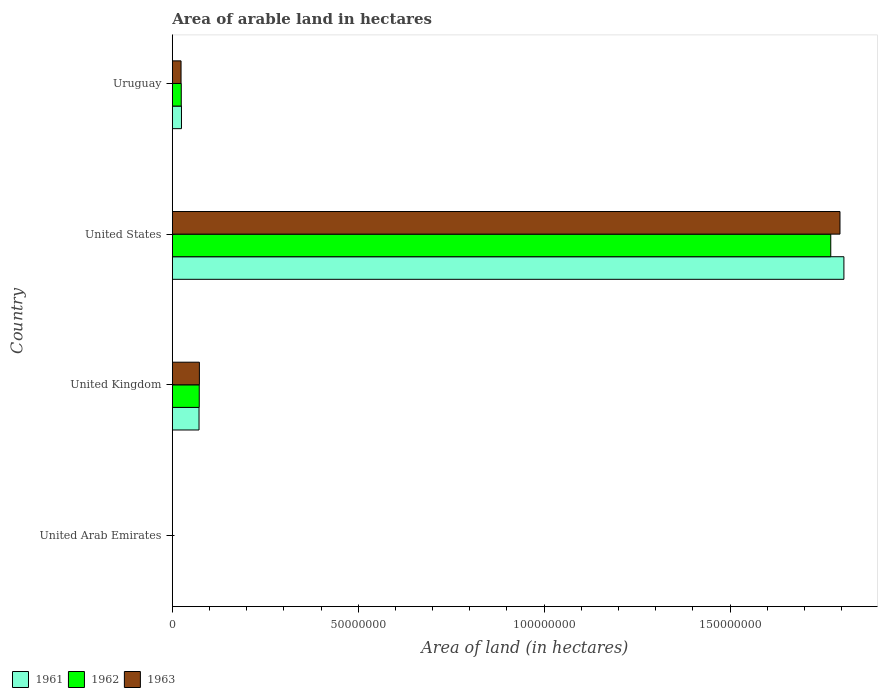How many bars are there on the 4th tick from the bottom?
Your answer should be compact. 3. What is the total arable land in 1962 in United Arab Emirates?
Your response must be concise. 5000. Across all countries, what is the maximum total arable land in 1963?
Ensure brevity in your answer.  1.80e+08. Across all countries, what is the minimum total arable land in 1963?
Provide a succinct answer. 5000. In which country was the total arable land in 1962 minimum?
Your answer should be compact. United Arab Emirates. What is the total total arable land in 1962 in the graph?
Make the answer very short. 1.87e+08. What is the difference between the total arable land in 1962 in United Kingdom and that in United States?
Provide a succinct answer. -1.70e+08. What is the difference between the total arable land in 1961 in United Kingdom and the total arable land in 1963 in United States?
Your response must be concise. -1.72e+08. What is the average total arable land in 1961 per country?
Provide a succinct answer. 4.76e+07. What is the difference between the total arable land in 1961 and total arable land in 1962 in United Kingdom?
Ensure brevity in your answer.  -6.10e+04. In how many countries, is the total arable land in 1963 greater than 20000000 hectares?
Ensure brevity in your answer.  1. What is the ratio of the total arable land in 1963 in United Kingdom to that in Uruguay?
Offer a very short reply. 3.11. Is the difference between the total arable land in 1961 in United Kingdom and United States greater than the difference between the total arable land in 1962 in United Kingdom and United States?
Your response must be concise. No. What is the difference between the highest and the second highest total arable land in 1961?
Your response must be concise. 1.73e+08. What is the difference between the highest and the lowest total arable land in 1961?
Offer a terse response. 1.81e+08. Is it the case that in every country, the sum of the total arable land in 1962 and total arable land in 1961 is greater than the total arable land in 1963?
Provide a succinct answer. Yes. How many bars are there?
Provide a succinct answer. 12. Are all the bars in the graph horizontal?
Offer a very short reply. Yes. What is the difference between two consecutive major ticks on the X-axis?
Your answer should be compact. 5.00e+07. Does the graph contain any zero values?
Give a very brief answer. No. Does the graph contain grids?
Make the answer very short. No. How are the legend labels stacked?
Your answer should be compact. Horizontal. What is the title of the graph?
Your response must be concise. Area of arable land in hectares. Does "2000" appear as one of the legend labels in the graph?
Provide a succinct answer. No. What is the label or title of the X-axis?
Make the answer very short. Area of land (in hectares). What is the label or title of the Y-axis?
Provide a succinct answer. Country. What is the Area of land (in hectares) in 1963 in United Arab Emirates?
Provide a short and direct response. 5000. What is the Area of land (in hectares) of 1961 in United Kingdom?
Make the answer very short. 7.18e+06. What is the Area of land (in hectares) of 1962 in United Kingdom?
Make the answer very short. 7.24e+06. What is the Area of land (in hectares) in 1963 in United Kingdom?
Your answer should be compact. 7.28e+06. What is the Area of land (in hectares) of 1961 in United States?
Provide a succinct answer. 1.81e+08. What is the Area of land (in hectares) in 1962 in United States?
Your answer should be very brief. 1.77e+08. What is the Area of land (in hectares) of 1963 in United States?
Make the answer very short. 1.80e+08. What is the Area of land (in hectares) in 1961 in Uruguay?
Provide a succinct answer. 2.45e+06. What is the Area of land (in hectares) of 1962 in Uruguay?
Your answer should be very brief. 2.40e+06. What is the Area of land (in hectares) of 1963 in Uruguay?
Offer a terse response. 2.34e+06. Across all countries, what is the maximum Area of land (in hectares) of 1961?
Give a very brief answer. 1.81e+08. Across all countries, what is the maximum Area of land (in hectares) of 1962?
Keep it short and to the point. 1.77e+08. Across all countries, what is the maximum Area of land (in hectares) in 1963?
Provide a short and direct response. 1.80e+08. Across all countries, what is the minimum Area of land (in hectares) in 1962?
Give a very brief answer. 5000. What is the total Area of land (in hectares) in 1961 in the graph?
Offer a very short reply. 1.90e+08. What is the total Area of land (in hectares) in 1962 in the graph?
Offer a very short reply. 1.87e+08. What is the total Area of land (in hectares) in 1963 in the graph?
Your response must be concise. 1.89e+08. What is the difference between the Area of land (in hectares) of 1961 in United Arab Emirates and that in United Kingdom?
Your answer should be compact. -7.17e+06. What is the difference between the Area of land (in hectares) in 1962 in United Arab Emirates and that in United Kingdom?
Give a very brief answer. -7.23e+06. What is the difference between the Area of land (in hectares) in 1963 in United Arab Emirates and that in United Kingdom?
Make the answer very short. -7.27e+06. What is the difference between the Area of land (in hectares) in 1961 in United Arab Emirates and that in United States?
Ensure brevity in your answer.  -1.81e+08. What is the difference between the Area of land (in hectares) in 1962 in United Arab Emirates and that in United States?
Your response must be concise. -1.77e+08. What is the difference between the Area of land (in hectares) in 1963 in United Arab Emirates and that in United States?
Give a very brief answer. -1.80e+08. What is the difference between the Area of land (in hectares) in 1961 in United Arab Emirates and that in Uruguay?
Ensure brevity in your answer.  -2.45e+06. What is the difference between the Area of land (in hectares) of 1962 in United Arab Emirates and that in Uruguay?
Keep it short and to the point. -2.39e+06. What is the difference between the Area of land (in hectares) in 1963 in United Arab Emirates and that in Uruguay?
Your response must be concise. -2.33e+06. What is the difference between the Area of land (in hectares) of 1961 in United Kingdom and that in United States?
Your response must be concise. -1.73e+08. What is the difference between the Area of land (in hectares) of 1962 in United Kingdom and that in United States?
Give a very brief answer. -1.70e+08. What is the difference between the Area of land (in hectares) of 1963 in United Kingdom and that in United States?
Ensure brevity in your answer.  -1.72e+08. What is the difference between the Area of land (in hectares) of 1961 in United Kingdom and that in Uruguay?
Your answer should be compact. 4.72e+06. What is the difference between the Area of land (in hectares) of 1962 in United Kingdom and that in Uruguay?
Your answer should be compact. 4.84e+06. What is the difference between the Area of land (in hectares) of 1963 in United Kingdom and that in Uruguay?
Your answer should be compact. 4.94e+06. What is the difference between the Area of land (in hectares) in 1961 in United States and that in Uruguay?
Offer a terse response. 1.78e+08. What is the difference between the Area of land (in hectares) of 1962 in United States and that in Uruguay?
Provide a short and direct response. 1.75e+08. What is the difference between the Area of land (in hectares) in 1963 in United States and that in Uruguay?
Offer a very short reply. 1.77e+08. What is the difference between the Area of land (in hectares) of 1961 in United Arab Emirates and the Area of land (in hectares) of 1962 in United Kingdom?
Your answer should be very brief. -7.23e+06. What is the difference between the Area of land (in hectares) of 1961 in United Arab Emirates and the Area of land (in hectares) of 1963 in United Kingdom?
Make the answer very short. -7.27e+06. What is the difference between the Area of land (in hectares) in 1962 in United Arab Emirates and the Area of land (in hectares) in 1963 in United Kingdom?
Make the answer very short. -7.27e+06. What is the difference between the Area of land (in hectares) of 1961 in United Arab Emirates and the Area of land (in hectares) of 1962 in United States?
Ensure brevity in your answer.  -1.77e+08. What is the difference between the Area of land (in hectares) of 1961 in United Arab Emirates and the Area of land (in hectares) of 1963 in United States?
Offer a terse response. -1.80e+08. What is the difference between the Area of land (in hectares) in 1962 in United Arab Emirates and the Area of land (in hectares) in 1963 in United States?
Provide a short and direct response. -1.80e+08. What is the difference between the Area of land (in hectares) in 1961 in United Arab Emirates and the Area of land (in hectares) in 1962 in Uruguay?
Provide a succinct answer. -2.39e+06. What is the difference between the Area of land (in hectares) of 1961 in United Arab Emirates and the Area of land (in hectares) of 1963 in Uruguay?
Provide a succinct answer. -2.33e+06. What is the difference between the Area of land (in hectares) in 1962 in United Arab Emirates and the Area of land (in hectares) in 1963 in Uruguay?
Ensure brevity in your answer.  -2.33e+06. What is the difference between the Area of land (in hectares) of 1961 in United Kingdom and the Area of land (in hectares) of 1962 in United States?
Provide a succinct answer. -1.70e+08. What is the difference between the Area of land (in hectares) in 1961 in United Kingdom and the Area of land (in hectares) in 1963 in United States?
Keep it short and to the point. -1.72e+08. What is the difference between the Area of land (in hectares) in 1962 in United Kingdom and the Area of land (in hectares) in 1963 in United States?
Offer a very short reply. -1.72e+08. What is the difference between the Area of land (in hectares) in 1961 in United Kingdom and the Area of land (in hectares) in 1962 in Uruguay?
Provide a short and direct response. 4.78e+06. What is the difference between the Area of land (in hectares) of 1961 in United Kingdom and the Area of land (in hectares) of 1963 in Uruguay?
Your response must be concise. 4.84e+06. What is the difference between the Area of land (in hectares) in 1962 in United Kingdom and the Area of land (in hectares) in 1963 in Uruguay?
Offer a terse response. 4.90e+06. What is the difference between the Area of land (in hectares) in 1961 in United States and the Area of land (in hectares) in 1962 in Uruguay?
Your response must be concise. 1.78e+08. What is the difference between the Area of land (in hectares) of 1961 in United States and the Area of land (in hectares) of 1963 in Uruguay?
Provide a short and direct response. 1.78e+08. What is the difference between the Area of land (in hectares) in 1962 in United States and the Area of land (in hectares) in 1963 in Uruguay?
Provide a short and direct response. 1.75e+08. What is the average Area of land (in hectares) of 1961 per country?
Provide a short and direct response. 4.76e+07. What is the average Area of land (in hectares) in 1962 per country?
Offer a very short reply. 4.67e+07. What is the average Area of land (in hectares) in 1963 per country?
Provide a succinct answer. 4.73e+07. What is the difference between the Area of land (in hectares) of 1962 and Area of land (in hectares) of 1963 in United Arab Emirates?
Make the answer very short. 0. What is the difference between the Area of land (in hectares) in 1961 and Area of land (in hectares) in 1962 in United Kingdom?
Ensure brevity in your answer.  -6.10e+04. What is the difference between the Area of land (in hectares) of 1961 and Area of land (in hectares) of 1963 in United Kingdom?
Your response must be concise. -1.00e+05. What is the difference between the Area of land (in hectares) of 1962 and Area of land (in hectares) of 1963 in United Kingdom?
Provide a succinct answer. -3.90e+04. What is the difference between the Area of land (in hectares) in 1961 and Area of land (in hectares) in 1962 in United States?
Give a very brief answer. 3.54e+06. What is the difference between the Area of land (in hectares) of 1961 and Area of land (in hectares) of 1963 in United States?
Make the answer very short. 1.06e+06. What is the difference between the Area of land (in hectares) in 1962 and Area of land (in hectares) in 1963 in United States?
Your answer should be compact. -2.48e+06. What is the difference between the Area of land (in hectares) of 1961 and Area of land (in hectares) of 1962 in Uruguay?
Your answer should be compact. 5.80e+04. What is the difference between the Area of land (in hectares) of 1961 and Area of land (in hectares) of 1963 in Uruguay?
Provide a succinct answer. 1.16e+05. What is the difference between the Area of land (in hectares) of 1962 and Area of land (in hectares) of 1963 in Uruguay?
Make the answer very short. 5.80e+04. What is the ratio of the Area of land (in hectares) in 1961 in United Arab Emirates to that in United Kingdom?
Provide a succinct answer. 0. What is the ratio of the Area of land (in hectares) of 1962 in United Arab Emirates to that in United Kingdom?
Provide a succinct answer. 0. What is the ratio of the Area of land (in hectares) of 1963 in United Arab Emirates to that in United Kingdom?
Provide a succinct answer. 0. What is the ratio of the Area of land (in hectares) of 1961 in United Arab Emirates to that in United States?
Provide a succinct answer. 0. What is the ratio of the Area of land (in hectares) of 1961 in United Arab Emirates to that in Uruguay?
Keep it short and to the point. 0. What is the ratio of the Area of land (in hectares) of 1962 in United Arab Emirates to that in Uruguay?
Give a very brief answer. 0. What is the ratio of the Area of land (in hectares) in 1963 in United Arab Emirates to that in Uruguay?
Your answer should be very brief. 0. What is the ratio of the Area of land (in hectares) in 1961 in United Kingdom to that in United States?
Offer a very short reply. 0.04. What is the ratio of the Area of land (in hectares) in 1962 in United Kingdom to that in United States?
Provide a succinct answer. 0.04. What is the ratio of the Area of land (in hectares) in 1963 in United Kingdom to that in United States?
Offer a very short reply. 0.04. What is the ratio of the Area of land (in hectares) in 1961 in United Kingdom to that in Uruguay?
Give a very brief answer. 2.92. What is the ratio of the Area of land (in hectares) of 1962 in United Kingdom to that in Uruguay?
Your response must be concise. 3.02. What is the ratio of the Area of land (in hectares) of 1963 in United Kingdom to that in Uruguay?
Your answer should be compact. 3.11. What is the ratio of the Area of land (in hectares) in 1961 in United States to that in Uruguay?
Give a very brief answer. 73.61. What is the ratio of the Area of land (in hectares) in 1962 in United States to that in Uruguay?
Give a very brief answer. 73.91. What is the ratio of the Area of land (in hectares) of 1963 in United States to that in Uruguay?
Make the answer very short. 76.81. What is the difference between the highest and the second highest Area of land (in hectares) of 1961?
Ensure brevity in your answer.  1.73e+08. What is the difference between the highest and the second highest Area of land (in hectares) in 1962?
Your answer should be compact. 1.70e+08. What is the difference between the highest and the second highest Area of land (in hectares) of 1963?
Your answer should be very brief. 1.72e+08. What is the difference between the highest and the lowest Area of land (in hectares) of 1961?
Your answer should be compact. 1.81e+08. What is the difference between the highest and the lowest Area of land (in hectares) of 1962?
Offer a very short reply. 1.77e+08. What is the difference between the highest and the lowest Area of land (in hectares) of 1963?
Your response must be concise. 1.80e+08. 